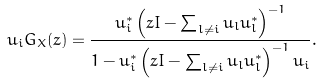Convert formula to latex. <formula><loc_0><loc_0><loc_500><loc_500>u _ { i } G _ { X } ( z ) = \frac { u _ { i } ^ { * } \left ( z I - \sum _ { l \neq i } u _ { l } u _ { l } ^ { * } \right ) ^ { - 1 } } { 1 - u _ { i } ^ { * } \left ( z I - \sum _ { l \neq i } u _ { l } u _ { l } ^ { * } \right ) ^ { - 1 } u _ { i } } .</formula> 